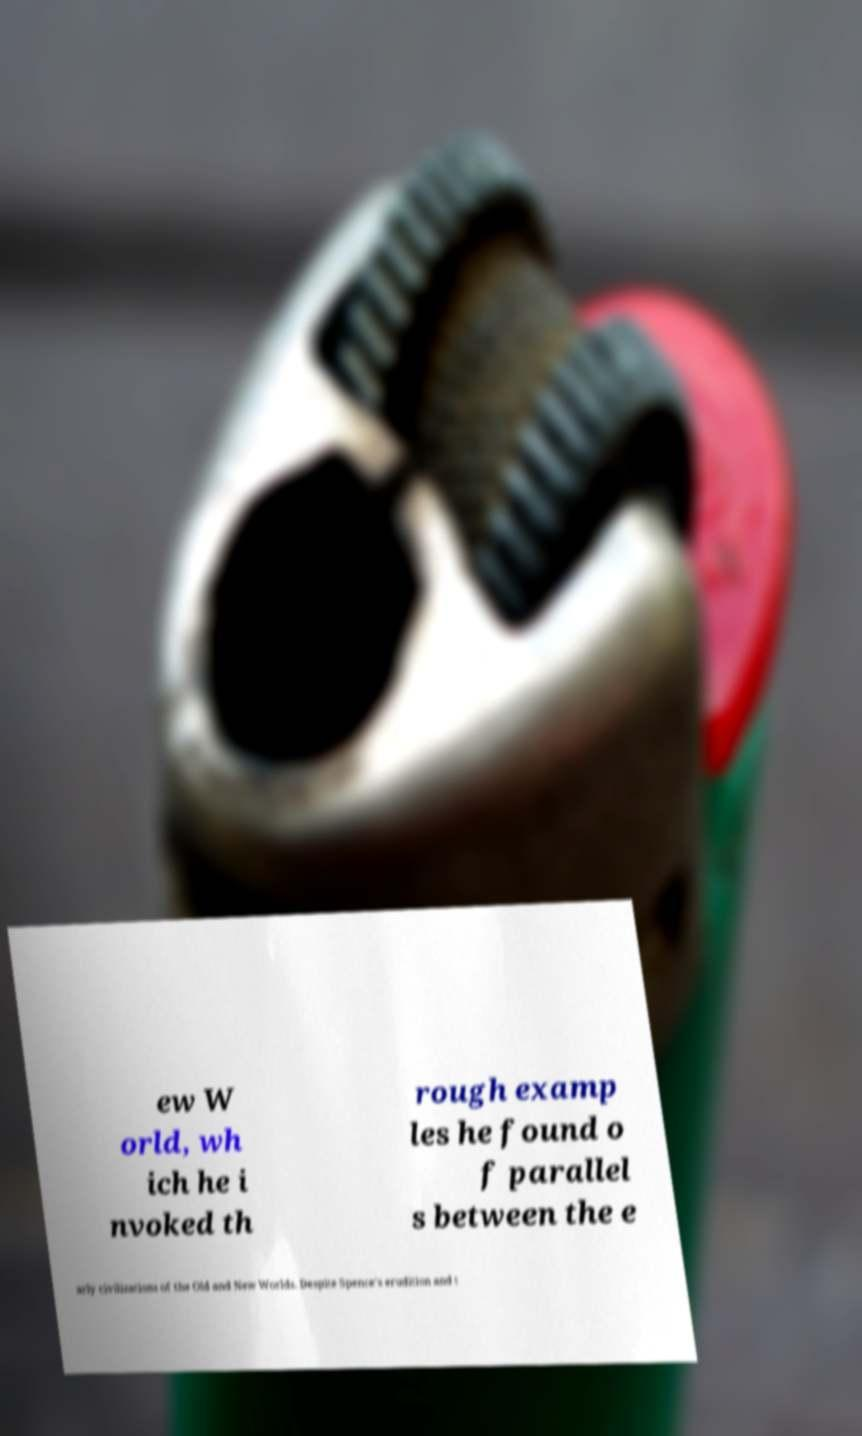Please identify and transcribe the text found in this image. ew W orld, wh ich he i nvoked th rough examp les he found o f parallel s between the e arly civilizations of the Old and New Worlds. Despite Spence's erudition and t 